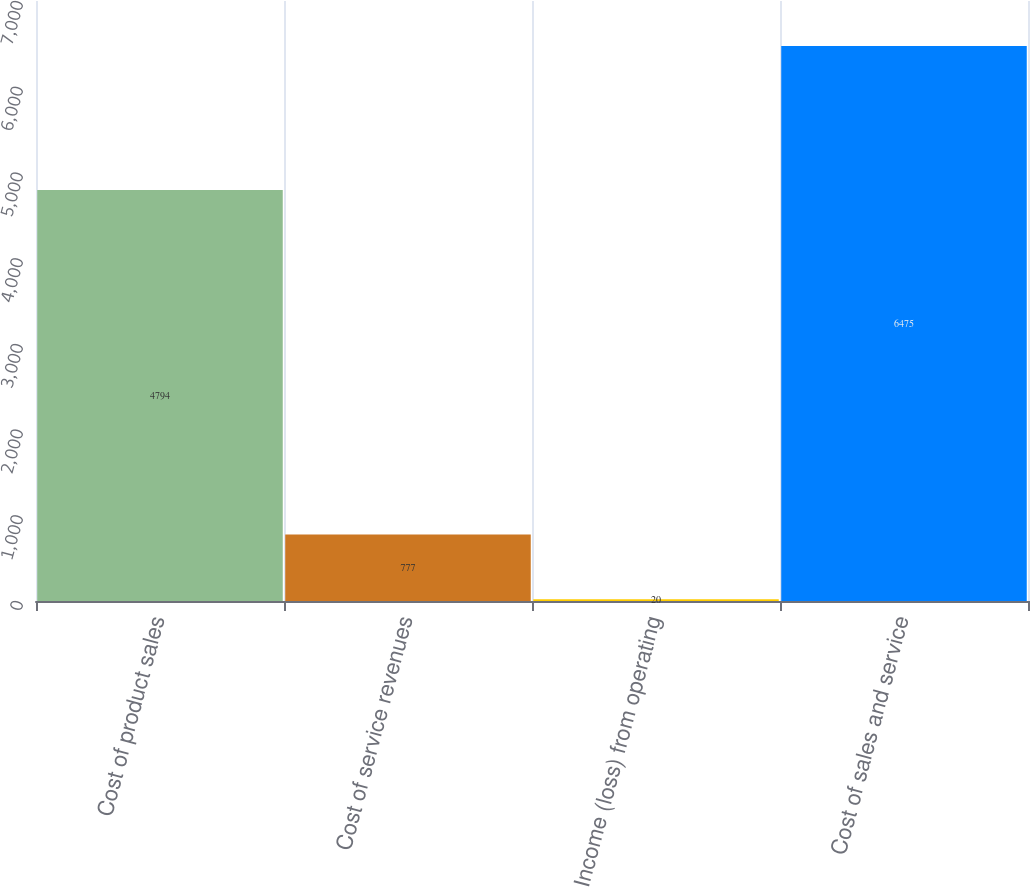<chart> <loc_0><loc_0><loc_500><loc_500><bar_chart><fcel>Cost of product sales<fcel>Cost of service revenues<fcel>Income (loss) from operating<fcel>Cost of sales and service<nl><fcel>4794<fcel>777<fcel>20<fcel>6475<nl></chart> 